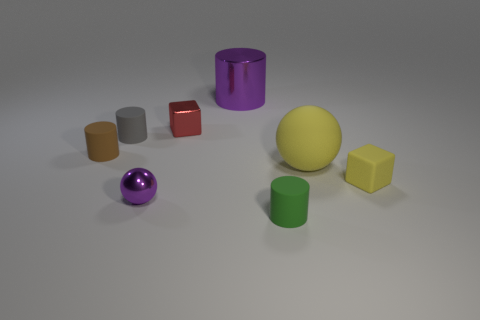There is a brown object that is the same size as the yellow matte cube; what shape is it?
Provide a succinct answer. Cylinder. What number of large matte things have the same color as the tiny rubber cube?
Keep it short and to the point. 1. Is the number of gray rubber cylinders in front of the tiny gray matte thing less than the number of metal cubes that are on the left side of the small purple metallic ball?
Make the answer very short. No. There is a metal block; are there any tiny purple metal objects on the left side of it?
Provide a short and direct response. Yes. Is there a brown rubber cylinder that is behind the tiny metallic thing to the right of the purple shiny object in front of the yellow matte sphere?
Your response must be concise. No. Is the shape of the purple metal object right of the tiny red block the same as  the gray matte thing?
Ensure brevity in your answer.  Yes. What is the color of the cube that is the same material as the small gray object?
Make the answer very short. Yellow. What number of cylinders have the same material as the large yellow sphere?
Offer a very short reply. 3. There is a ball that is behind the small yellow matte object in front of the metallic thing on the right side of the red metallic block; what color is it?
Provide a succinct answer. Yellow. Do the metal ball and the gray rubber thing have the same size?
Give a very brief answer. Yes. 